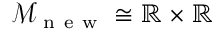Convert formula to latex. <formula><loc_0><loc_0><loc_500><loc_500>\mathcal { M } _ { n e w } \cong \mathbb { R } \times \mathbb { R }</formula> 